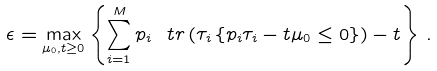<formula> <loc_0><loc_0><loc_500><loc_500>\epsilon = \max _ { \mu _ { 0 } , t \geq 0 } \left \{ \sum _ { i = 1 } ^ { M } p _ { i } \ t r \left ( \tau _ { i } \left \{ p _ { i } \tau _ { i } - t \mu _ { 0 } \leq 0 \right \} \right ) - t \right \} \, .</formula> 